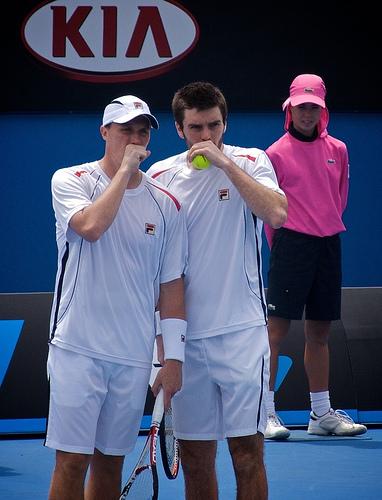What color shirt is the person in the back wearing?
Quick response, please. Pink. Which hand is holding the racket?
Write a very short answer. Left. How many people are wearing white?
Keep it brief. 2. Who is sponsoring this event?
Answer briefly. Kia. What company is sponsoring this game?
Give a very brief answer. Kia. What color of baseball cap is the lady wearing?
Give a very brief answer. Pink. 